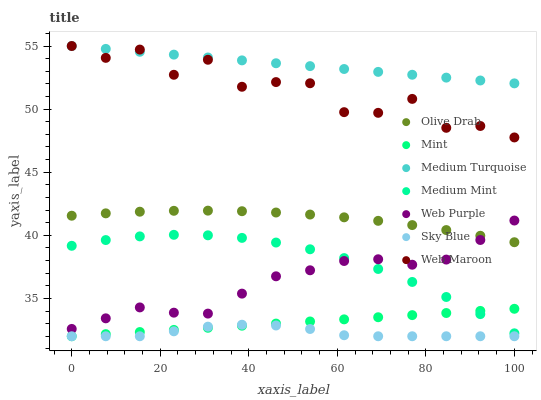Does Sky Blue have the minimum area under the curve?
Answer yes or no. Yes. Does Medium Turquoise have the maximum area under the curve?
Answer yes or no. Yes. Does Web Maroon have the minimum area under the curve?
Answer yes or no. No. Does Web Maroon have the maximum area under the curve?
Answer yes or no. No. Is Medium Turquoise the smoothest?
Answer yes or no. Yes. Is Web Maroon the roughest?
Answer yes or no. Yes. Is Web Purple the smoothest?
Answer yes or no. No. Is Web Purple the roughest?
Answer yes or no. No. Does Sky Blue have the lowest value?
Answer yes or no. Yes. Does Web Maroon have the lowest value?
Answer yes or no. No. Does Medium Turquoise have the highest value?
Answer yes or no. Yes. Does Web Purple have the highest value?
Answer yes or no. No. Is Olive Drab less than Medium Turquoise?
Answer yes or no. Yes. Is Web Purple greater than Sky Blue?
Answer yes or no. Yes. Does Web Maroon intersect Medium Turquoise?
Answer yes or no. Yes. Is Web Maroon less than Medium Turquoise?
Answer yes or no. No. Is Web Maroon greater than Medium Turquoise?
Answer yes or no. No. Does Olive Drab intersect Medium Turquoise?
Answer yes or no. No. 